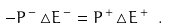Convert formula to latex. <formula><loc_0><loc_0><loc_500><loc_500>- P ^ { \, - } \, \triangle E ^ { \, - } = P ^ { \, + } \, \triangle E ^ { \, + } \ .</formula> 